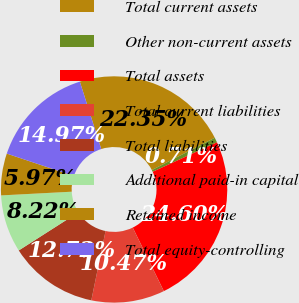Convert chart. <chart><loc_0><loc_0><loc_500><loc_500><pie_chart><fcel>Total current assets<fcel>Other non-current assets<fcel>Total assets<fcel>Total current liabilities<fcel>Total liabilities<fcel>Additional paid-in capital<fcel>Retained income<fcel>Total equity-controlling<nl><fcel>22.35%<fcel>0.71%<fcel>24.6%<fcel>10.47%<fcel>12.72%<fcel>8.22%<fcel>5.97%<fcel>14.97%<nl></chart> 